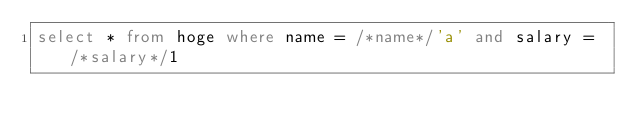<code> <loc_0><loc_0><loc_500><loc_500><_SQL_>select * from hoge where name = /*name*/'a' and salary = /*salary*/1</code> 